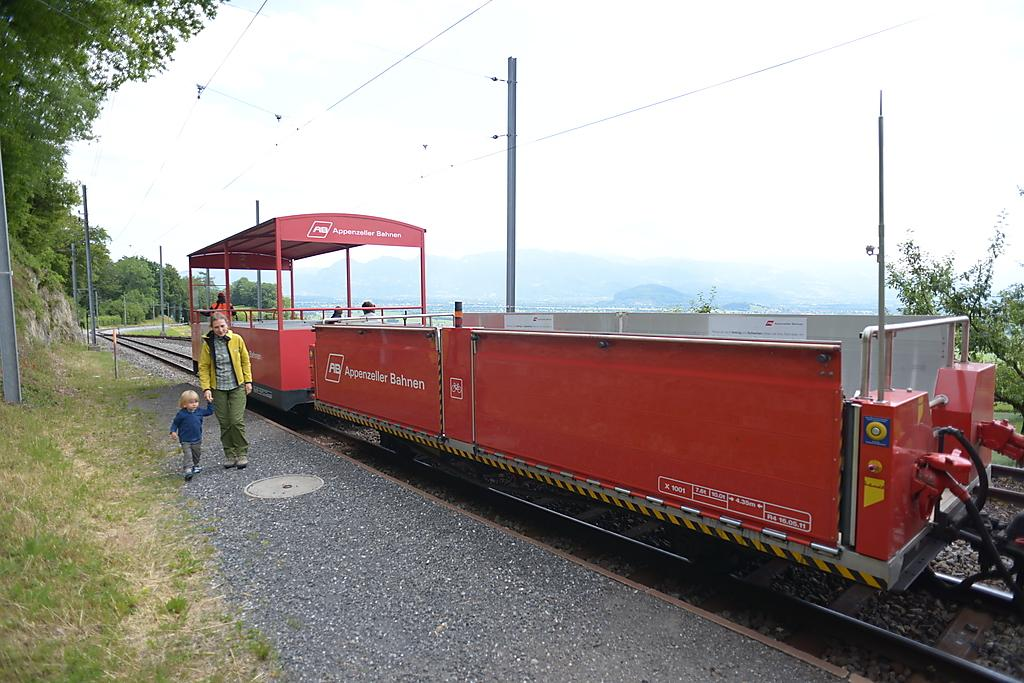What is the main subject of the image? The main subject of the image is a train. Where is the train located in the image? The train is on a train track. What is the color of the train track? The train track is red in color. Who else can be seen in the image besides the train? There is a kid and a person in the image. What other objects or features can be seen in the image? There are poles, trees, and plants in the image. What type of spot can be seen on the train in the image? There is no spot visible on the train in the image. How many stars are visible in the image? There are no stars visible in the image. 